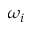Convert formula to latex. <formula><loc_0><loc_0><loc_500><loc_500>\omega _ { i }</formula> 